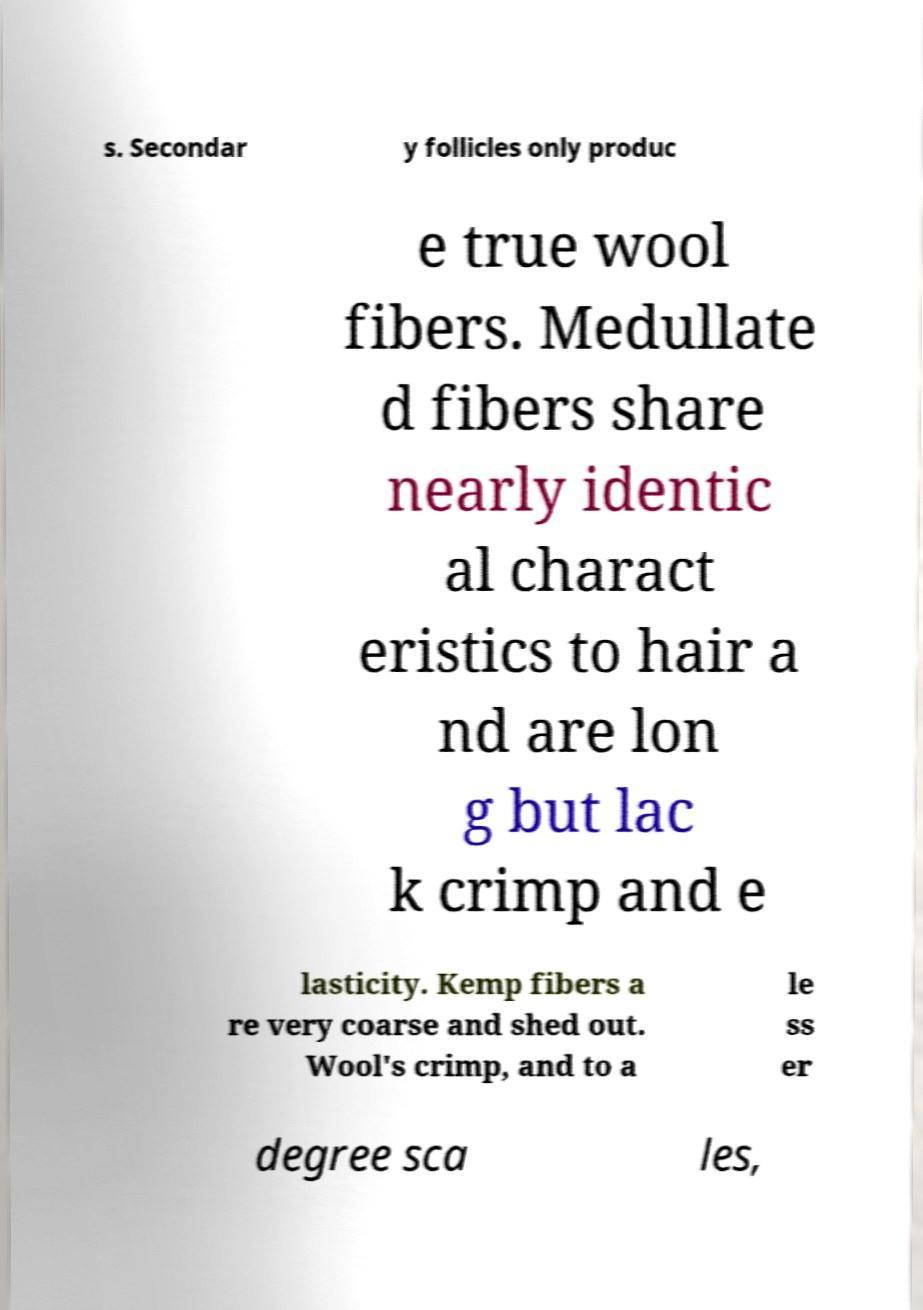Can you accurately transcribe the text from the provided image for me? s. Secondar y follicles only produc e true wool fibers. Medullate d fibers share nearly identic al charact eristics to hair a nd are lon g but lac k crimp and e lasticity. Kemp fibers a re very coarse and shed out. Wool's crimp, and to a le ss er degree sca les, 